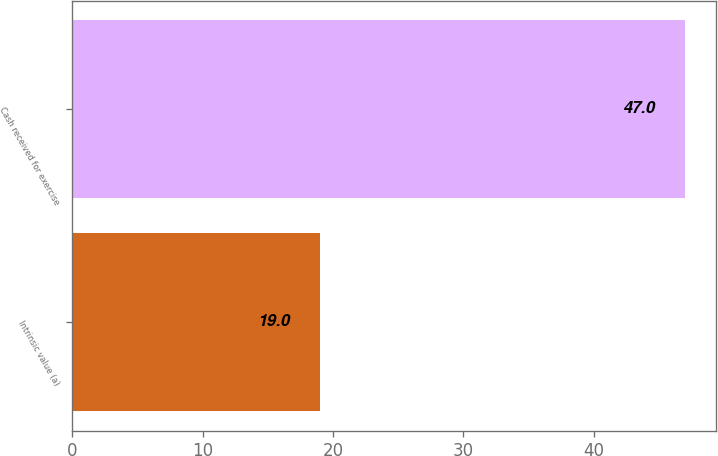Convert chart to OTSL. <chart><loc_0><loc_0><loc_500><loc_500><bar_chart><fcel>Intrinsic value (a)<fcel>Cash received for exercise<nl><fcel>19<fcel>47<nl></chart> 